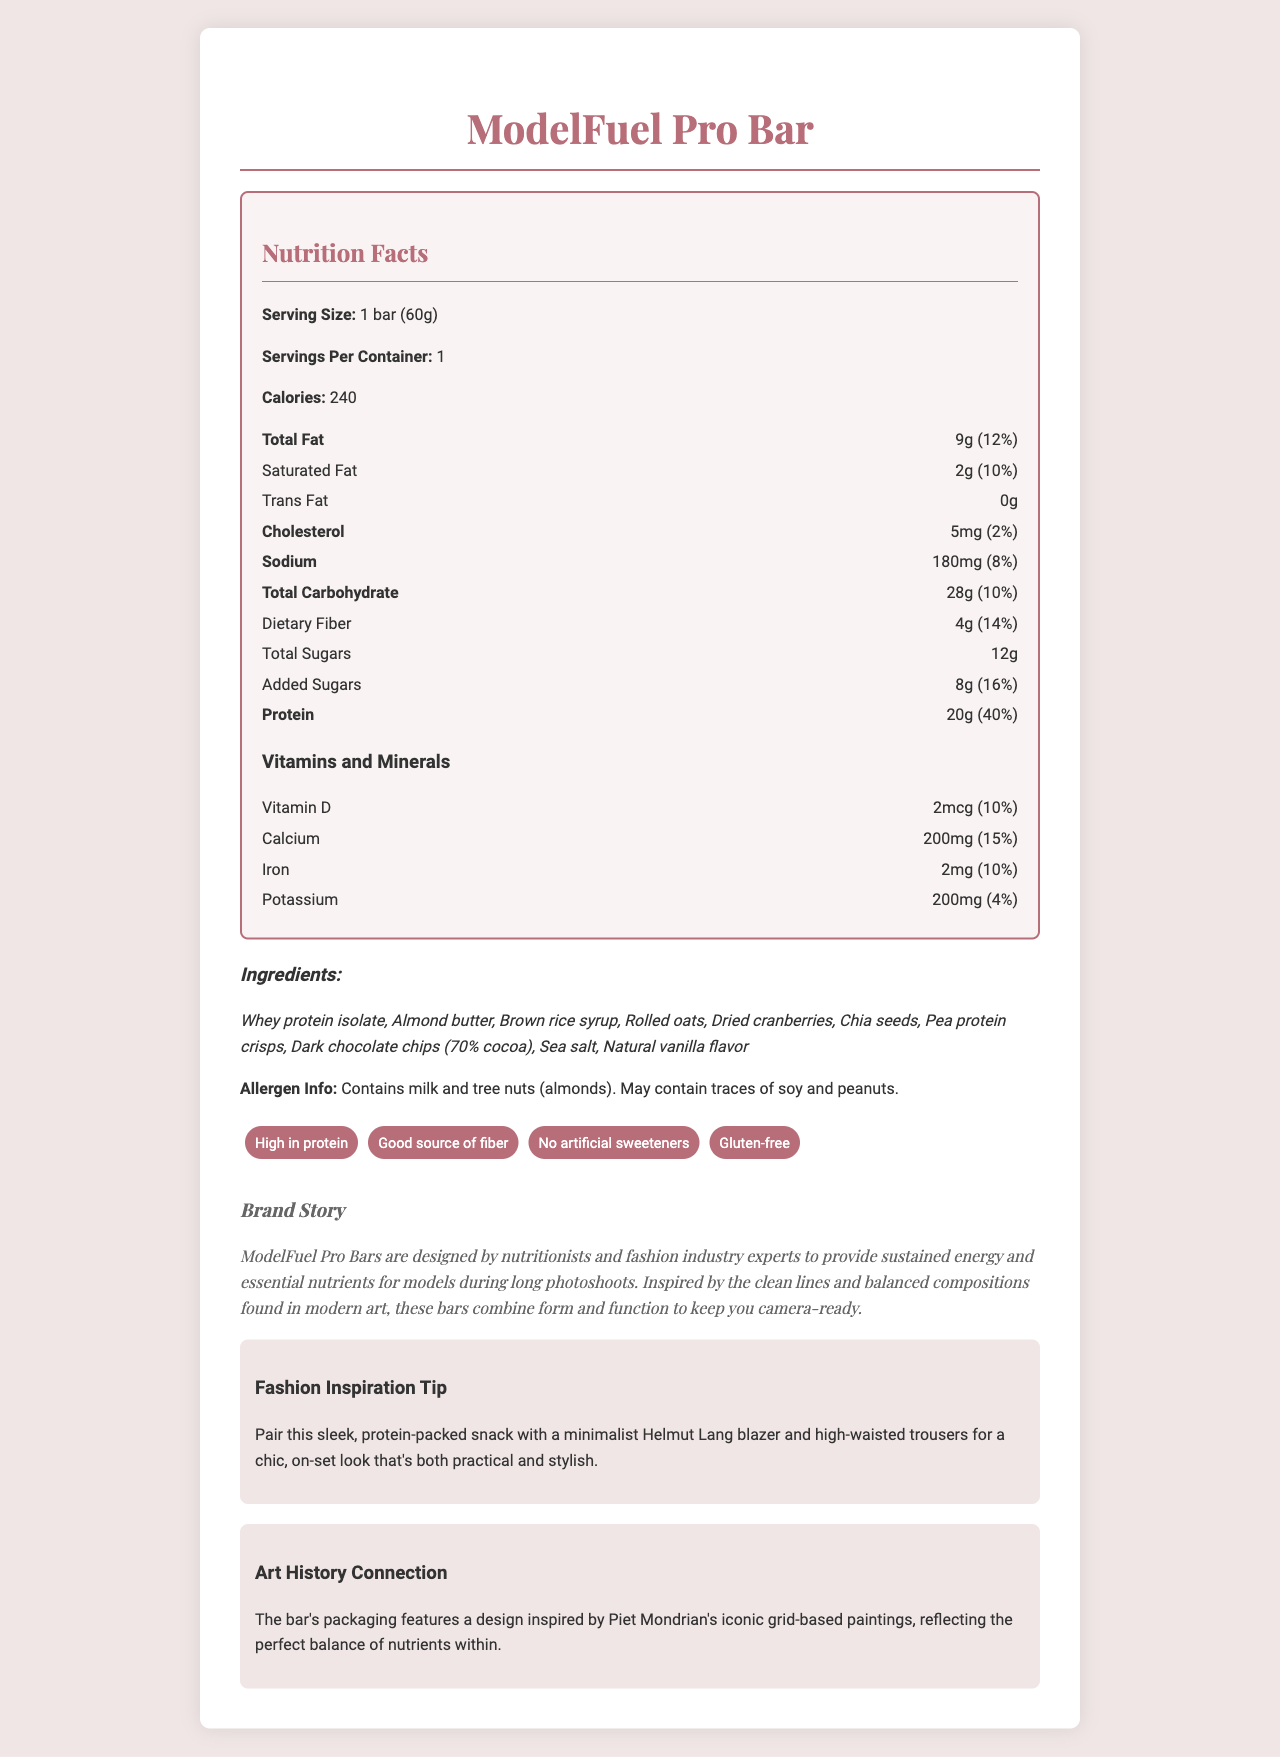what is the serving size of the ModelFuel Pro Bar? The serving size is explicitly mentioned at the beginning of the nutrition facts section.
Answer: 1 bar (60g) how many calories are there in one serving of the ModelFuel Pro Bar? The document lists 240 calories per serving in the nutrition facts section.
Answer: 240 what type of protein does the ModelFuel Pro Bar contain? The ingredients section lists whey protein isolate and pea protein crisps as types of protein contained in the bar.
Answer: Whey protein isolate and pea protein crisps which vitamins and minerals are present in the ModelFuel Pro Bar? The vitamins and minerals section lists Vitamin D, Calcium, Iron, and Potassium.
Answer: Vitamin D, Calcium, Iron, Potassium What percentage of the daily value for protein does the ModelFuel Pro Bar provide? The nutrition facts state that the protein content provides 40% of the daily value.
Answer: 40% How much sodium does the ModelFuel Pro Bar contain? The document indicates that the bar contains 180mg of sodium.
Answer: 180mg which statement is true regarding the ModelFuel Pro Bar? A. It contains artificial sweeteners B. It is not gluten-free C. It contains 200mg of calcium D. It contains trans fat It is stated that the bar contains 200mg of calcium.
Answer: C which of the following allergens are mentioned in the allergen information? A. Soy B. Peanuts C. Tree nuts (almonds) D. All of the above The allergen information states that it contains milk, tree nuts (almonds), and may contain traces of soy and peanuts.
Answer: D is the ModelFuel Pro Bar a good source of dietary fiber? The nutrition claims include "Good source of fiber," and the dietary fiber content is listed as 14% of the daily value.
Answer: Yes summarize the main idea of the document. The document gives comprehensive details about the nutritional content of the bar and highlights its suitability for models with a narrative connecting it to fashion and modern art.
Answer: The document provides detailed nutrition facts, ingredients, allergen information, and claims about the ModelFuel Pro Bar, a high-protein snack bar designed for models. It also connects the bar to fashion and art. can the bar's packaging design be described based on the information provided? The document mentions that the packaging design is inspired by Piet Mondrian’s grid-based paintings, but it doesn’t visually depict the actual design of the packaging.
Answer: No 